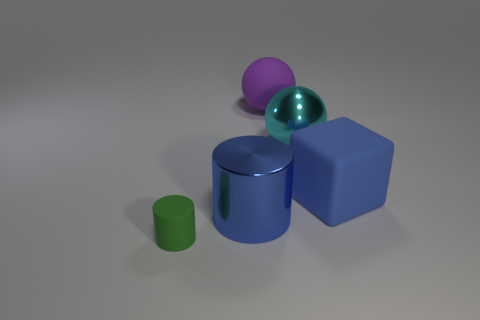There is a thing that is the same color as the metallic cylinder; what is its shape?
Offer a very short reply. Cube. Is there anything else that is the same size as the green thing?
Your response must be concise. No. What color is the big thing that is both in front of the metal sphere and to the left of the big cyan ball?
Ensure brevity in your answer.  Blue. Is the number of large metal balls that are in front of the purple ball greater than the number of large yellow metal cubes?
Offer a terse response. Yes. Are any tiny green rubber cylinders visible?
Provide a succinct answer. Yes. Does the large matte cube have the same color as the rubber cylinder?
Provide a succinct answer. No. What number of large things are either cubes or cylinders?
Offer a very short reply. 2. Are there any other things of the same color as the matte block?
Offer a terse response. Yes. What shape is the tiny green thing that is made of the same material as the cube?
Offer a terse response. Cylinder. There is a sphere that is in front of the purple rubber thing; how big is it?
Offer a terse response. Large. 